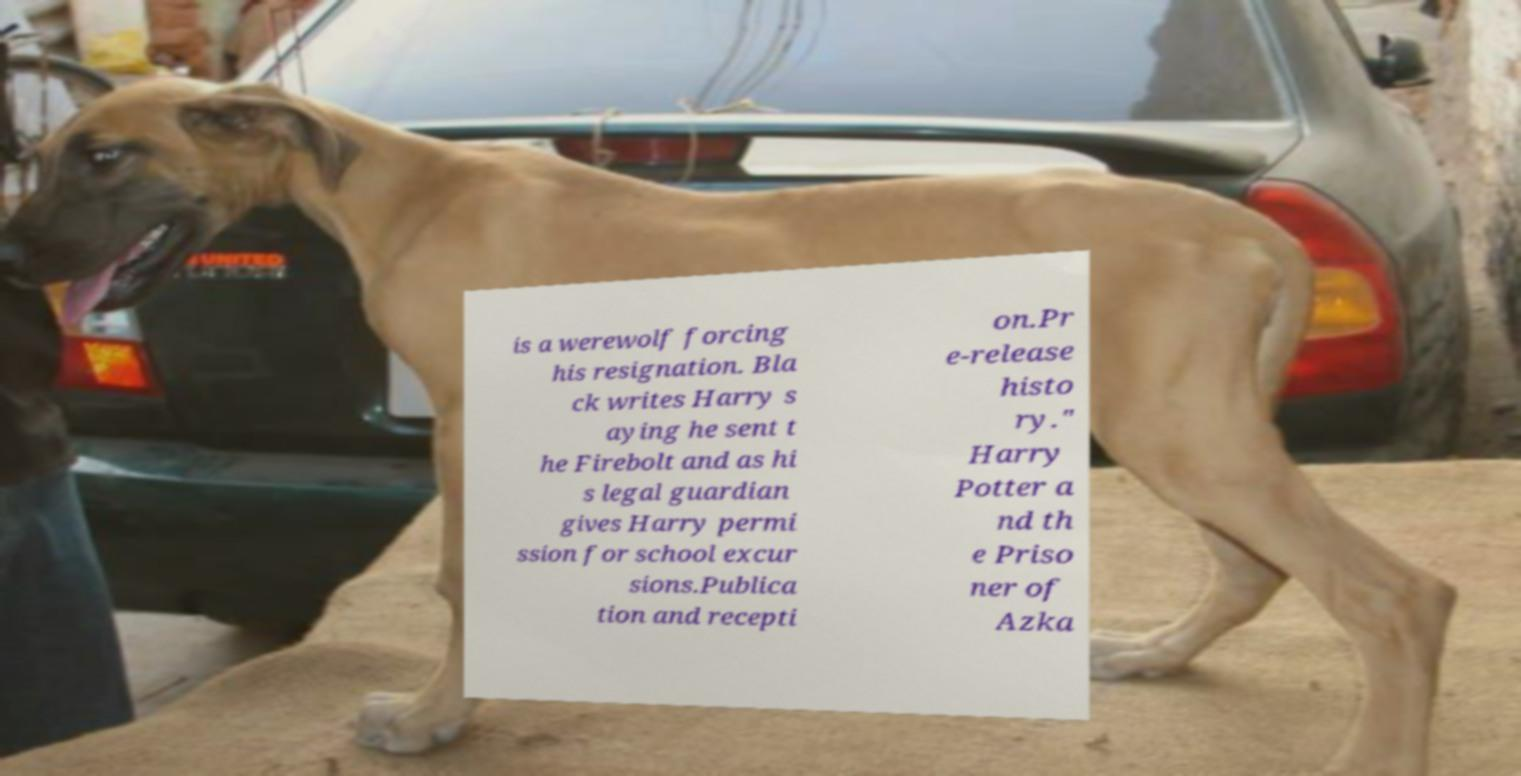For documentation purposes, I need the text within this image transcribed. Could you provide that? is a werewolf forcing his resignation. Bla ck writes Harry s aying he sent t he Firebolt and as hi s legal guardian gives Harry permi ssion for school excur sions.Publica tion and recepti on.Pr e-release histo ry." Harry Potter a nd th e Priso ner of Azka 